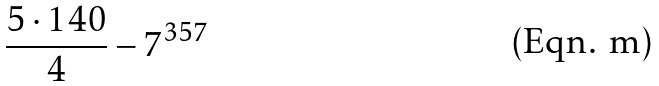Convert formula to latex. <formula><loc_0><loc_0><loc_500><loc_500>\frac { 5 \cdot 1 4 0 } { 4 } - 7 ^ { 3 5 7 }</formula> 